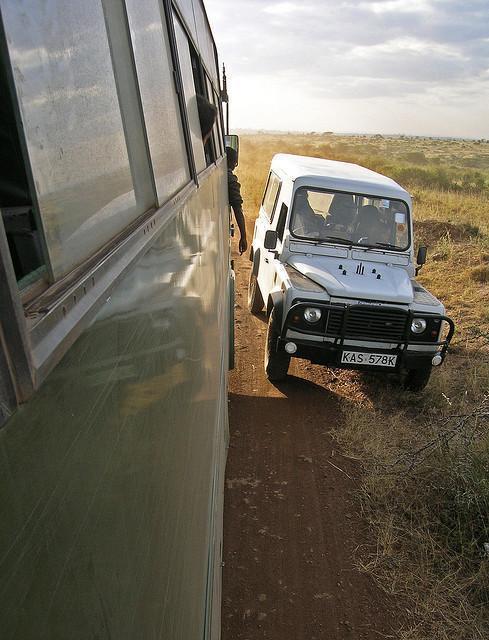In what environment are the Jeep and bus travelling?
Answer the question by selecting the correct answer among the 4 following choices and explain your choice with a short sentence. The answer should be formatted with the following format: `Answer: choice
Rationale: rationale.`
Options: Savannah, forest, desert, tundra. Answer: savannah.
Rationale: A flat expanse of land with few trees can be seen behind a jeep and another vehicle. jeeps are used in the savannah. 